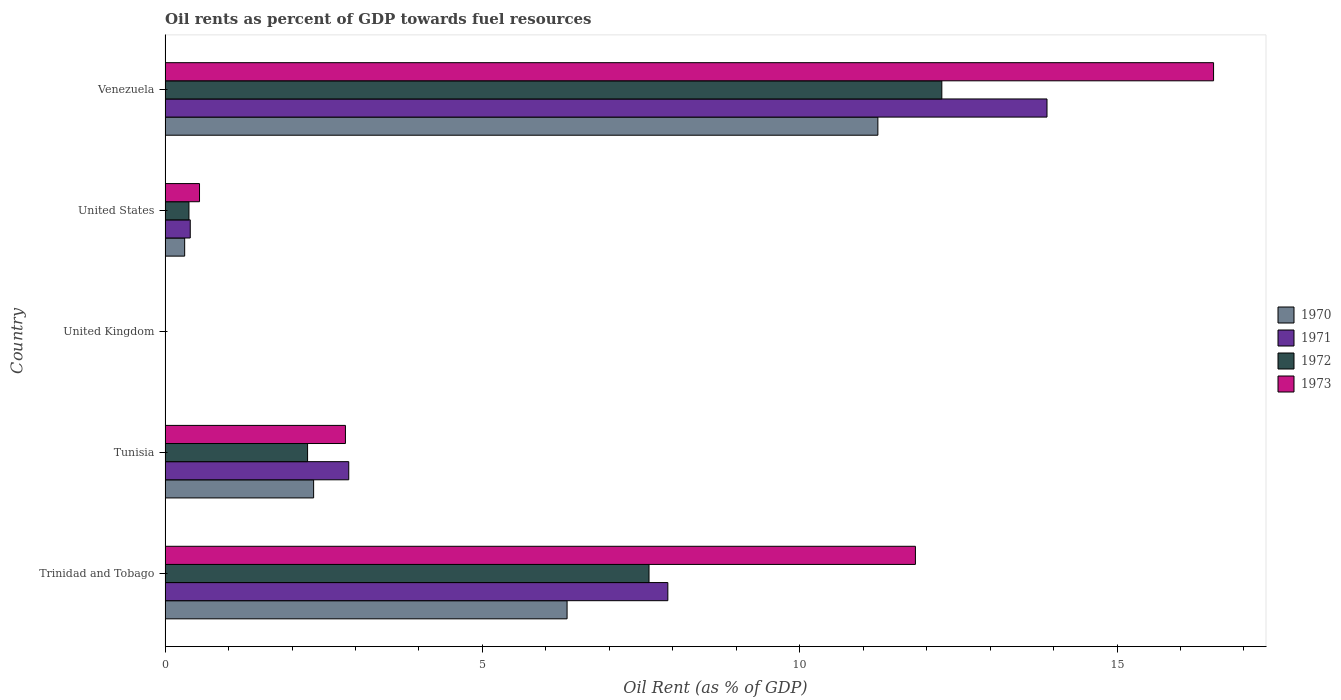How many bars are there on the 5th tick from the top?
Provide a succinct answer. 4. How many bars are there on the 1st tick from the bottom?
Your response must be concise. 4. What is the label of the 5th group of bars from the top?
Your response must be concise. Trinidad and Tobago. What is the oil rent in 1973 in Tunisia?
Make the answer very short. 2.84. Across all countries, what is the maximum oil rent in 1973?
Your answer should be very brief. 16.52. Across all countries, what is the minimum oil rent in 1970?
Ensure brevity in your answer.  0. In which country was the oil rent in 1970 maximum?
Give a very brief answer. Venezuela. In which country was the oil rent in 1970 minimum?
Keep it short and to the point. United Kingdom. What is the total oil rent in 1972 in the graph?
Provide a short and direct response. 22.49. What is the difference between the oil rent in 1973 in United Kingdom and that in Venezuela?
Provide a short and direct response. -16.52. What is the difference between the oil rent in 1970 in Venezuela and the oil rent in 1972 in United States?
Give a very brief answer. 10.86. What is the average oil rent in 1973 per country?
Offer a very short reply. 6.35. What is the difference between the oil rent in 1972 and oil rent in 1973 in Trinidad and Tobago?
Your response must be concise. -4.2. What is the ratio of the oil rent in 1971 in United Kingdom to that in United States?
Provide a short and direct response. 0. Is the difference between the oil rent in 1972 in United Kingdom and Venezuela greater than the difference between the oil rent in 1973 in United Kingdom and Venezuela?
Your response must be concise. Yes. What is the difference between the highest and the second highest oil rent in 1973?
Provide a succinct answer. 4.7. What is the difference between the highest and the lowest oil rent in 1970?
Provide a succinct answer. 11.23. Is the sum of the oil rent in 1972 in Tunisia and Venezuela greater than the maximum oil rent in 1970 across all countries?
Provide a short and direct response. Yes. What does the 3rd bar from the top in United States represents?
Your answer should be very brief. 1971. What is the difference between two consecutive major ticks on the X-axis?
Ensure brevity in your answer.  5. Where does the legend appear in the graph?
Your response must be concise. Center right. How many legend labels are there?
Ensure brevity in your answer.  4. What is the title of the graph?
Keep it short and to the point. Oil rents as percent of GDP towards fuel resources. Does "1971" appear as one of the legend labels in the graph?
Make the answer very short. Yes. What is the label or title of the X-axis?
Make the answer very short. Oil Rent (as % of GDP). What is the label or title of the Y-axis?
Provide a succinct answer. Country. What is the Oil Rent (as % of GDP) of 1970 in Trinidad and Tobago?
Make the answer very short. 6.33. What is the Oil Rent (as % of GDP) in 1971 in Trinidad and Tobago?
Provide a short and direct response. 7.92. What is the Oil Rent (as % of GDP) of 1972 in Trinidad and Tobago?
Offer a terse response. 7.63. What is the Oil Rent (as % of GDP) in 1973 in Trinidad and Tobago?
Keep it short and to the point. 11.82. What is the Oil Rent (as % of GDP) of 1970 in Tunisia?
Your answer should be compact. 2.34. What is the Oil Rent (as % of GDP) in 1971 in Tunisia?
Ensure brevity in your answer.  2.89. What is the Oil Rent (as % of GDP) in 1972 in Tunisia?
Provide a succinct answer. 2.25. What is the Oil Rent (as % of GDP) in 1973 in Tunisia?
Your answer should be very brief. 2.84. What is the Oil Rent (as % of GDP) of 1970 in United Kingdom?
Your answer should be very brief. 0. What is the Oil Rent (as % of GDP) of 1971 in United Kingdom?
Your answer should be very brief. 0. What is the Oil Rent (as % of GDP) of 1972 in United Kingdom?
Give a very brief answer. 0. What is the Oil Rent (as % of GDP) of 1973 in United Kingdom?
Your answer should be very brief. 0. What is the Oil Rent (as % of GDP) of 1970 in United States?
Provide a short and direct response. 0.31. What is the Oil Rent (as % of GDP) of 1971 in United States?
Your answer should be very brief. 0.4. What is the Oil Rent (as % of GDP) in 1972 in United States?
Make the answer very short. 0.38. What is the Oil Rent (as % of GDP) of 1973 in United States?
Ensure brevity in your answer.  0.54. What is the Oil Rent (as % of GDP) in 1970 in Venezuela?
Ensure brevity in your answer.  11.23. What is the Oil Rent (as % of GDP) of 1971 in Venezuela?
Provide a succinct answer. 13.9. What is the Oil Rent (as % of GDP) in 1972 in Venezuela?
Give a very brief answer. 12.24. What is the Oil Rent (as % of GDP) of 1973 in Venezuela?
Offer a terse response. 16.52. Across all countries, what is the maximum Oil Rent (as % of GDP) of 1970?
Ensure brevity in your answer.  11.23. Across all countries, what is the maximum Oil Rent (as % of GDP) in 1971?
Give a very brief answer. 13.9. Across all countries, what is the maximum Oil Rent (as % of GDP) in 1972?
Make the answer very short. 12.24. Across all countries, what is the maximum Oil Rent (as % of GDP) in 1973?
Offer a very short reply. 16.52. Across all countries, what is the minimum Oil Rent (as % of GDP) of 1970?
Your response must be concise. 0. Across all countries, what is the minimum Oil Rent (as % of GDP) of 1971?
Offer a terse response. 0. Across all countries, what is the minimum Oil Rent (as % of GDP) in 1972?
Keep it short and to the point. 0. Across all countries, what is the minimum Oil Rent (as % of GDP) in 1973?
Offer a terse response. 0. What is the total Oil Rent (as % of GDP) in 1970 in the graph?
Make the answer very short. 20.22. What is the total Oil Rent (as % of GDP) in 1971 in the graph?
Provide a succinct answer. 25.11. What is the total Oil Rent (as % of GDP) of 1972 in the graph?
Your answer should be compact. 22.49. What is the total Oil Rent (as % of GDP) of 1973 in the graph?
Keep it short and to the point. 31.73. What is the difference between the Oil Rent (as % of GDP) in 1970 in Trinidad and Tobago and that in Tunisia?
Keep it short and to the point. 3.99. What is the difference between the Oil Rent (as % of GDP) of 1971 in Trinidad and Tobago and that in Tunisia?
Give a very brief answer. 5.03. What is the difference between the Oil Rent (as % of GDP) in 1972 in Trinidad and Tobago and that in Tunisia?
Your answer should be very brief. 5.38. What is the difference between the Oil Rent (as % of GDP) of 1973 in Trinidad and Tobago and that in Tunisia?
Provide a short and direct response. 8.98. What is the difference between the Oil Rent (as % of GDP) in 1970 in Trinidad and Tobago and that in United Kingdom?
Ensure brevity in your answer.  6.33. What is the difference between the Oil Rent (as % of GDP) of 1971 in Trinidad and Tobago and that in United Kingdom?
Provide a short and direct response. 7.92. What is the difference between the Oil Rent (as % of GDP) of 1972 in Trinidad and Tobago and that in United Kingdom?
Keep it short and to the point. 7.62. What is the difference between the Oil Rent (as % of GDP) in 1973 in Trinidad and Tobago and that in United Kingdom?
Your response must be concise. 11.82. What is the difference between the Oil Rent (as % of GDP) of 1970 in Trinidad and Tobago and that in United States?
Your answer should be very brief. 6.03. What is the difference between the Oil Rent (as % of GDP) of 1971 in Trinidad and Tobago and that in United States?
Offer a terse response. 7.53. What is the difference between the Oil Rent (as % of GDP) in 1972 in Trinidad and Tobago and that in United States?
Give a very brief answer. 7.25. What is the difference between the Oil Rent (as % of GDP) of 1973 in Trinidad and Tobago and that in United States?
Make the answer very short. 11.28. What is the difference between the Oil Rent (as % of GDP) of 1970 in Trinidad and Tobago and that in Venezuela?
Offer a terse response. -4.9. What is the difference between the Oil Rent (as % of GDP) of 1971 in Trinidad and Tobago and that in Venezuela?
Offer a terse response. -5.97. What is the difference between the Oil Rent (as % of GDP) in 1972 in Trinidad and Tobago and that in Venezuela?
Make the answer very short. -4.61. What is the difference between the Oil Rent (as % of GDP) of 1973 in Trinidad and Tobago and that in Venezuela?
Make the answer very short. -4.7. What is the difference between the Oil Rent (as % of GDP) in 1970 in Tunisia and that in United Kingdom?
Give a very brief answer. 2.34. What is the difference between the Oil Rent (as % of GDP) of 1971 in Tunisia and that in United Kingdom?
Ensure brevity in your answer.  2.89. What is the difference between the Oil Rent (as % of GDP) in 1972 in Tunisia and that in United Kingdom?
Ensure brevity in your answer.  2.24. What is the difference between the Oil Rent (as % of GDP) in 1973 in Tunisia and that in United Kingdom?
Your response must be concise. 2.84. What is the difference between the Oil Rent (as % of GDP) in 1970 in Tunisia and that in United States?
Ensure brevity in your answer.  2.03. What is the difference between the Oil Rent (as % of GDP) of 1971 in Tunisia and that in United States?
Provide a short and direct response. 2.5. What is the difference between the Oil Rent (as % of GDP) of 1972 in Tunisia and that in United States?
Provide a succinct answer. 1.87. What is the difference between the Oil Rent (as % of GDP) of 1973 in Tunisia and that in United States?
Offer a very short reply. 2.3. What is the difference between the Oil Rent (as % of GDP) of 1970 in Tunisia and that in Venezuela?
Provide a succinct answer. -8.89. What is the difference between the Oil Rent (as % of GDP) in 1971 in Tunisia and that in Venezuela?
Your response must be concise. -11. What is the difference between the Oil Rent (as % of GDP) in 1972 in Tunisia and that in Venezuela?
Your response must be concise. -9.99. What is the difference between the Oil Rent (as % of GDP) in 1973 in Tunisia and that in Venezuela?
Ensure brevity in your answer.  -13.68. What is the difference between the Oil Rent (as % of GDP) of 1970 in United Kingdom and that in United States?
Your answer should be very brief. -0.31. What is the difference between the Oil Rent (as % of GDP) of 1971 in United Kingdom and that in United States?
Your answer should be very brief. -0.4. What is the difference between the Oil Rent (as % of GDP) in 1972 in United Kingdom and that in United States?
Offer a very short reply. -0.37. What is the difference between the Oil Rent (as % of GDP) in 1973 in United Kingdom and that in United States?
Your answer should be very brief. -0.54. What is the difference between the Oil Rent (as % of GDP) in 1970 in United Kingdom and that in Venezuela?
Your answer should be very brief. -11.23. What is the difference between the Oil Rent (as % of GDP) of 1971 in United Kingdom and that in Venezuela?
Your answer should be very brief. -13.9. What is the difference between the Oil Rent (as % of GDP) in 1972 in United Kingdom and that in Venezuela?
Give a very brief answer. -12.24. What is the difference between the Oil Rent (as % of GDP) of 1973 in United Kingdom and that in Venezuela?
Your answer should be very brief. -16.52. What is the difference between the Oil Rent (as % of GDP) in 1970 in United States and that in Venezuela?
Offer a very short reply. -10.92. What is the difference between the Oil Rent (as % of GDP) of 1971 in United States and that in Venezuela?
Keep it short and to the point. -13.5. What is the difference between the Oil Rent (as % of GDP) in 1972 in United States and that in Venezuela?
Offer a terse response. -11.86. What is the difference between the Oil Rent (as % of GDP) of 1973 in United States and that in Venezuela?
Provide a succinct answer. -15.98. What is the difference between the Oil Rent (as % of GDP) in 1970 in Trinidad and Tobago and the Oil Rent (as % of GDP) in 1971 in Tunisia?
Your response must be concise. 3.44. What is the difference between the Oil Rent (as % of GDP) of 1970 in Trinidad and Tobago and the Oil Rent (as % of GDP) of 1972 in Tunisia?
Your answer should be very brief. 4.09. What is the difference between the Oil Rent (as % of GDP) in 1970 in Trinidad and Tobago and the Oil Rent (as % of GDP) in 1973 in Tunisia?
Offer a very short reply. 3.49. What is the difference between the Oil Rent (as % of GDP) in 1971 in Trinidad and Tobago and the Oil Rent (as % of GDP) in 1972 in Tunisia?
Keep it short and to the point. 5.68. What is the difference between the Oil Rent (as % of GDP) of 1971 in Trinidad and Tobago and the Oil Rent (as % of GDP) of 1973 in Tunisia?
Your response must be concise. 5.08. What is the difference between the Oil Rent (as % of GDP) in 1972 in Trinidad and Tobago and the Oil Rent (as % of GDP) in 1973 in Tunisia?
Your response must be concise. 4.78. What is the difference between the Oil Rent (as % of GDP) of 1970 in Trinidad and Tobago and the Oil Rent (as % of GDP) of 1971 in United Kingdom?
Provide a short and direct response. 6.33. What is the difference between the Oil Rent (as % of GDP) of 1970 in Trinidad and Tobago and the Oil Rent (as % of GDP) of 1972 in United Kingdom?
Ensure brevity in your answer.  6.33. What is the difference between the Oil Rent (as % of GDP) in 1970 in Trinidad and Tobago and the Oil Rent (as % of GDP) in 1973 in United Kingdom?
Give a very brief answer. 6.33. What is the difference between the Oil Rent (as % of GDP) in 1971 in Trinidad and Tobago and the Oil Rent (as % of GDP) in 1972 in United Kingdom?
Keep it short and to the point. 7.92. What is the difference between the Oil Rent (as % of GDP) of 1971 in Trinidad and Tobago and the Oil Rent (as % of GDP) of 1973 in United Kingdom?
Offer a very short reply. 7.92. What is the difference between the Oil Rent (as % of GDP) of 1972 in Trinidad and Tobago and the Oil Rent (as % of GDP) of 1973 in United Kingdom?
Give a very brief answer. 7.62. What is the difference between the Oil Rent (as % of GDP) in 1970 in Trinidad and Tobago and the Oil Rent (as % of GDP) in 1971 in United States?
Provide a succinct answer. 5.94. What is the difference between the Oil Rent (as % of GDP) in 1970 in Trinidad and Tobago and the Oil Rent (as % of GDP) in 1972 in United States?
Your response must be concise. 5.96. What is the difference between the Oil Rent (as % of GDP) in 1970 in Trinidad and Tobago and the Oil Rent (as % of GDP) in 1973 in United States?
Provide a short and direct response. 5.79. What is the difference between the Oil Rent (as % of GDP) of 1971 in Trinidad and Tobago and the Oil Rent (as % of GDP) of 1972 in United States?
Provide a succinct answer. 7.55. What is the difference between the Oil Rent (as % of GDP) in 1971 in Trinidad and Tobago and the Oil Rent (as % of GDP) in 1973 in United States?
Give a very brief answer. 7.38. What is the difference between the Oil Rent (as % of GDP) in 1972 in Trinidad and Tobago and the Oil Rent (as % of GDP) in 1973 in United States?
Keep it short and to the point. 7.08. What is the difference between the Oil Rent (as % of GDP) of 1970 in Trinidad and Tobago and the Oil Rent (as % of GDP) of 1971 in Venezuela?
Make the answer very short. -7.56. What is the difference between the Oil Rent (as % of GDP) in 1970 in Trinidad and Tobago and the Oil Rent (as % of GDP) in 1972 in Venezuela?
Your response must be concise. -5.91. What is the difference between the Oil Rent (as % of GDP) in 1970 in Trinidad and Tobago and the Oil Rent (as % of GDP) in 1973 in Venezuela?
Provide a short and direct response. -10.19. What is the difference between the Oil Rent (as % of GDP) in 1971 in Trinidad and Tobago and the Oil Rent (as % of GDP) in 1972 in Venezuela?
Provide a short and direct response. -4.32. What is the difference between the Oil Rent (as % of GDP) of 1971 in Trinidad and Tobago and the Oil Rent (as % of GDP) of 1973 in Venezuela?
Your response must be concise. -8.6. What is the difference between the Oil Rent (as % of GDP) in 1972 in Trinidad and Tobago and the Oil Rent (as % of GDP) in 1973 in Venezuela?
Offer a very short reply. -8.9. What is the difference between the Oil Rent (as % of GDP) in 1970 in Tunisia and the Oil Rent (as % of GDP) in 1971 in United Kingdom?
Give a very brief answer. 2.34. What is the difference between the Oil Rent (as % of GDP) of 1970 in Tunisia and the Oil Rent (as % of GDP) of 1972 in United Kingdom?
Make the answer very short. 2.34. What is the difference between the Oil Rent (as % of GDP) of 1970 in Tunisia and the Oil Rent (as % of GDP) of 1973 in United Kingdom?
Keep it short and to the point. 2.34. What is the difference between the Oil Rent (as % of GDP) of 1971 in Tunisia and the Oil Rent (as % of GDP) of 1972 in United Kingdom?
Provide a succinct answer. 2.89. What is the difference between the Oil Rent (as % of GDP) in 1971 in Tunisia and the Oil Rent (as % of GDP) in 1973 in United Kingdom?
Offer a terse response. 2.89. What is the difference between the Oil Rent (as % of GDP) in 1972 in Tunisia and the Oil Rent (as % of GDP) in 1973 in United Kingdom?
Your answer should be very brief. 2.24. What is the difference between the Oil Rent (as % of GDP) in 1970 in Tunisia and the Oil Rent (as % of GDP) in 1971 in United States?
Provide a short and direct response. 1.94. What is the difference between the Oil Rent (as % of GDP) in 1970 in Tunisia and the Oil Rent (as % of GDP) in 1972 in United States?
Offer a terse response. 1.96. What is the difference between the Oil Rent (as % of GDP) in 1970 in Tunisia and the Oil Rent (as % of GDP) in 1973 in United States?
Give a very brief answer. 1.8. What is the difference between the Oil Rent (as % of GDP) of 1971 in Tunisia and the Oil Rent (as % of GDP) of 1972 in United States?
Keep it short and to the point. 2.52. What is the difference between the Oil Rent (as % of GDP) in 1971 in Tunisia and the Oil Rent (as % of GDP) in 1973 in United States?
Your answer should be compact. 2.35. What is the difference between the Oil Rent (as % of GDP) of 1972 in Tunisia and the Oil Rent (as % of GDP) of 1973 in United States?
Offer a very short reply. 1.7. What is the difference between the Oil Rent (as % of GDP) in 1970 in Tunisia and the Oil Rent (as % of GDP) in 1971 in Venezuela?
Offer a terse response. -11.56. What is the difference between the Oil Rent (as % of GDP) of 1970 in Tunisia and the Oil Rent (as % of GDP) of 1972 in Venezuela?
Your answer should be compact. -9.9. What is the difference between the Oil Rent (as % of GDP) in 1970 in Tunisia and the Oil Rent (as % of GDP) in 1973 in Venezuela?
Make the answer very short. -14.18. What is the difference between the Oil Rent (as % of GDP) of 1971 in Tunisia and the Oil Rent (as % of GDP) of 1972 in Venezuela?
Make the answer very short. -9.35. What is the difference between the Oil Rent (as % of GDP) of 1971 in Tunisia and the Oil Rent (as % of GDP) of 1973 in Venezuela?
Offer a terse response. -13.63. What is the difference between the Oil Rent (as % of GDP) of 1972 in Tunisia and the Oil Rent (as % of GDP) of 1973 in Venezuela?
Offer a terse response. -14.28. What is the difference between the Oil Rent (as % of GDP) in 1970 in United Kingdom and the Oil Rent (as % of GDP) in 1971 in United States?
Your response must be concise. -0.4. What is the difference between the Oil Rent (as % of GDP) in 1970 in United Kingdom and the Oil Rent (as % of GDP) in 1972 in United States?
Provide a short and direct response. -0.38. What is the difference between the Oil Rent (as % of GDP) in 1970 in United Kingdom and the Oil Rent (as % of GDP) in 1973 in United States?
Offer a terse response. -0.54. What is the difference between the Oil Rent (as % of GDP) of 1971 in United Kingdom and the Oil Rent (as % of GDP) of 1972 in United States?
Give a very brief answer. -0.38. What is the difference between the Oil Rent (as % of GDP) of 1971 in United Kingdom and the Oil Rent (as % of GDP) of 1973 in United States?
Your answer should be very brief. -0.54. What is the difference between the Oil Rent (as % of GDP) in 1972 in United Kingdom and the Oil Rent (as % of GDP) in 1973 in United States?
Make the answer very short. -0.54. What is the difference between the Oil Rent (as % of GDP) of 1970 in United Kingdom and the Oil Rent (as % of GDP) of 1971 in Venezuela?
Ensure brevity in your answer.  -13.9. What is the difference between the Oil Rent (as % of GDP) in 1970 in United Kingdom and the Oil Rent (as % of GDP) in 1972 in Venezuela?
Keep it short and to the point. -12.24. What is the difference between the Oil Rent (as % of GDP) in 1970 in United Kingdom and the Oil Rent (as % of GDP) in 1973 in Venezuela?
Offer a very short reply. -16.52. What is the difference between the Oil Rent (as % of GDP) in 1971 in United Kingdom and the Oil Rent (as % of GDP) in 1972 in Venezuela?
Give a very brief answer. -12.24. What is the difference between the Oil Rent (as % of GDP) in 1971 in United Kingdom and the Oil Rent (as % of GDP) in 1973 in Venezuela?
Offer a terse response. -16.52. What is the difference between the Oil Rent (as % of GDP) in 1972 in United Kingdom and the Oil Rent (as % of GDP) in 1973 in Venezuela?
Make the answer very short. -16.52. What is the difference between the Oil Rent (as % of GDP) of 1970 in United States and the Oil Rent (as % of GDP) of 1971 in Venezuela?
Your response must be concise. -13.59. What is the difference between the Oil Rent (as % of GDP) in 1970 in United States and the Oil Rent (as % of GDP) in 1972 in Venezuela?
Your answer should be compact. -11.93. What is the difference between the Oil Rent (as % of GDP) of 1970 in United States and the Oil Rent (as % of GDP) of 1973 in Venezuela?
Your answer should be very brief. -16.21. What is the difference between the Oil Rent (as % of GDP) in 1971 in United States and the Oil Rent (as % of GDP) in 1972 in Venezuela?
Offer a very short reply. -11.84. What is the difference between the Oil Rent (as % of GDP) of 1971 in United States and the Oil Rent (as % of GDP) of 1973 in Venezuela?
Ensure brevity in your answer.  -16.12. What is the difference between the Oil Rent (as % of GDP) in 1972 in United States and the Oil Rent (as % of GDP) in 1973 in Venezuela?
Your response must be concise. -16.15. What is the average Oil Rent (as % of GDP) of 1970 per country?
Your response must be concise. 4.04. What is the average Oil Rent (as % of GDP) in 1971 per country?
Your answer should be compact. 5.02. What is the average Oil Rent (as % of GDP) of 1972 per country?
Ensure brevity in your answer.  4.5. What is the average Oil Rent (as % of GDP) in 1973 per country?
Provide a succinct answer. 6.35. What is the difference between the Oil Rent (as % of GDP) in 1970 and Oil Rent (as % of GDP) in 1971 in Trinidad and Tobago?
Ensure brevity in your answer.  -1.59. What is the difference between the Oil Rent (as % of GDP) in 1970 and Oil Rent (as % of GDP) in 1972 in Trinidad and Tobago?
Your answer should be very brief. -1.29. What is the difference between the Oil Rent (as % of GDP) in 1970 and Oil Rent (as % of GDP) in 1973 in Trinidad and Tobago?
Provide a succinct answer. -5.49. What is the difference between the Oil Rent (as % of GDP) in 1971 and Oil Rent (as % of GDP) in 1972 in Trinidad and Tobago?
Offer a terse response. 0.3. What is the difference between the Oil Rent (as % of GDP) in 1971 and Oil Rent (as % of GDP) in 1973 in Trinidad and Tobago?
Offer a terse response. -3.9. What is the difference between the Oil Rent (as % of GDP) of 1972 and Oil Rent (as % of GDP) of 1973 in Trinidad and Tobago?
Keep it short and to the point. -4.2. What is the difference between the Oil Rent (as % of GDP) in 1970 and Oil Rent (as % of GDP) in 1971 in Tunisia?
Offer a terse response. -0.55. What is the difference between the Oil Rent (as % of GDP) in 1970 and Oil Rent (as % of GDP) in 1972 in Tunisia?
Give a very brief answer. 0.1. What is the difference between the Oil Rent (as % of GDP) in 1970 and Oil Rent (as % of GDP) in 1973 in Tunisia?
Provide a succinct answer. -0.5. What is the difference between the Oil Rent (as % of GDP) of 1971 and Oil Rent (as % of GDP) of 1972 in Tunisia?
Offer a terse response. 0.65. What is the difference between the Oil Rent (as % of GDP) of 1971 and Oil Rent (as % of GDP) of 1973 in Tunisia?
Your response must be concise. 0.05. What is the difference between the Oil Rent (as % of GDP) of 1972 and Oil Rent (as % of GDP) of 1973 in Tunisia?
Keep it short and to the point. -0.6. What is the difference between the Oil Rent (as % of GDP) in 1970 and Oil Rent (as % of GDP) in 1971 in United Kingdom?
Provide a short and direct response. 0. What is the difference between the Oil Rent (as % of GDP) in 1970 and Oil Rent (as % of GDP) in 1972 in United Kingdom?
Keep it short and to the point. -0. What is the difference between the Oil Rent (as % of GDP) in 1970 and Oil Rent (as % of GDP) in 1973 in United Kingdom?
Ensure brevity in your answer.  -0. What is the difference between the Oil Rent (as % of GDP) of 1971 and Oil Rent (as % of GDP) of 1972 in United Kingdom?
Your response must be concise. -0. What is the difference between the Oil Rent (as % of GDP) in 1971 and Oil Rent (as % of GDP) in 1973 in United Kingdom?
Make the answer very short. -0. What is the difference between the Oil Rent (as % of GDP) in 1972 and Oil Rent (as % of GDP) in 1973 in United Kingdom?
Your response must be concise. -0. What is the difference between the Oil Rent (as % of GDP) of 1970 and Oil Rent (as % of GDP) of 1971 in United States?
Ensure brevity in your answer.  -0.09. What is the difference between the Oil Rent (as % of GDP) of 1970 and Oil Rent (as % of GDP) of 1972 in United States?
Give a very brief answer. -0.07. What is the difference between the Oil Rent (as % of GDP) in 1970 and Oil Rent (as % of GDP) in 1973 in United States?
Your answer should be compact. -0.23. What is the difference between the Oil Rent (as % of GDP) of 1971 and Oil Rent (as % of GDP) of 1972 in United States?
Your answer should be compact. 0.02. What is the difference between the Oil Rent (as % of GDP) of 1971 and Oil Rent (as % of GDP) of 1973 in United States?
Your response must be concise. -0.15. What is the difference between the Oil Rent (as % of GDP) in 1972 and Oil Rent (as % of GDP) in 1973 in United States?
Offer a terse response. -0.17. What is the difference between the Oil Rent (as % of GDP) in 1970 and Oil Rent (as % of GDP) in 1971 in Venezuela?
Keep it short and to the point. -2.67. What is the difference between the Oil Rent (as % of GDP) in 1970 and Oil Rent (as % of GDP) in 1972 in Venezuela?
Give a very brief answer. -1.01. What is the difference between the Oil Rent (as % of GDP) in 1970 and Oil Rent (as % of GDP) in 1973 in Venezuela?
Provide a short and direct response. -5.29. What is the difference between the Oil Rent (as % of GDP) in 1971 and Oil Rent (as % of GDP) in 1972 in Venezuela?
Make the answer very short. 1.66. What is the difference between the Oil Rent (as % of GDP) of 1971 and Oil Rent (as % of GDP) of 1973 in Venezuela?
Provide a succinct answer. -2.62. What is the difference between the Oil Rent (as % of GDP) in 1972 and Oil Rent (as % of GDP) in 1973 in Venezuela?
Give a very brief answer. -4.28. What is the ratio of the Oil Rent (as % of GDP) of 1970 in Trinidad and Tobago to that in Tunisia?
Provide a short and direct response. 2.71. What is the ratio of the Oil Rent (as % of GDP) of 1971 in Trinidad and Tobago to that in Tunisia?
Your answer should be compact. 2.74. What is the ratio of the Oil Rent (as % of GDP) in 1972 in Trinidad and Tobago to that in Tunisia?
Your answer should be compact. 3.4. What is the ratio of the Oil Rent (as % of GDP) in 1973 in Trinidad and Tobago to that in Tunisia?
Offer a very short reply. 4.16. What is the ratio of the Oil Rent (as % of GDP) in 1970 in Trinidad and Tobago to that in United Kingdom?
Give a very brief answer. 7151.98. What is the ratio of the Oil Rent (as % of GDP) of 1971 in Trinidad and Tobago to that in United Kingdom?
Keep it short and to the point. 1.12e+04. What is the ratio of the Oil Rent (as % of GDP) of 1972 in Trinidad and Tobago to that in United Kingdom?
Your response must be concise. 5894.4. What is the ratio of the Oil Rent (as % of GDP) in 1973 in Trinidad and Tobago to that in United Kingdom?
Offer a very short reply. 5268.85. What is the ratio of the Oil Rent (as % of GDP) of 1970 in Trinidad and Tobago to that in United States?
Offer a very short reply. 20.53. What is the ratio of the Oil Rent (as % of GDP) in 1971 in Trinidad and Tobago to that in United States?
Your answer should be very brief. 19.98. What is the ratio of the Oil Rent (as % of GDP) of 1972 in Trinidad and Tobago to that in United States?
Keep it short and to the point. 20.29. What is the ratio of the Oil Rent (as % of GDP) of 1973 in Trinidad and Tobago to that in United States?
Make the answer very short. 21.8. What is the ratio of the Oil Rent (as % of GDP) in 1970 in Trinidad and Tobago to that in Venezuela?
Give a very brief answer. 0.56. What is the ratio of the Oil Rent (as % of GDP) in 1971 in Trinidad and Tobago to that in Venezuela?
Offer a very short reply. 0.57. What is the ratio of the Oil Rent (as % of GDP) in 1972 in Trinidad and Tobago to that in Venezuela?
Offer a very short reply. 0.62. What is the ratio of the Oil Rent (as % of GDP) in 1973 in Trinidad and Tobago to that in Venezuela?
Give a very brief answer. 0.72. What is the ratio of the Oil Rent (as % of GDP) of 1970 in Tunisia to that in United Kingdom?
Your answer should be compact. 2642.42. What is the ratio of the Oil Rent (as % of GDP) of 1971 in Tunisia to that in United Kingdom?
Make the answer very short. 4088.61. What is the ratio of the Oil Rent (as % of GDP) in 1972 in Tunisia to that in United Kingdom?
Make the answer very short. 1735.44. What is the ratio of the Oil Rent (as % of GDP) of 1973 in Tunisia to that in United Kingdom?
Make the answer very short. 1266.39. What is the ratio of the Oil Rent (as % of GDP) in 1970 in Tunisia to that in United States?
Provide a succinct answer. 7.59. What is the ratio of the Oil Rent (as % of GDP) of 1971 in Tunisia to that in United States?
Offer a very short reply. 7.3. What is the ratio of the Oil Rent (as % of GDP) of 1972 in Tunisia to that in United States?
Offer a very short reply. 5.97. What is the ratio of the Oil Rent (as % of GDP) in 1973 in Tunisia to that in United States?
Offer a terse response. 5.24. What is the ratio of the Oil Rent (as % of GDP) in 1970 in Tunisia to that in Venezuela?
Your answer should be compact. 0.21. What is the ratio of the Oil Rent (as % of GDP) of 1971 in Tunisia to that in Venezuela?
Ensure brevity in your answer.  0.21. What is the ratio of the Oil Rent (as % of GDP) of 1972 in Tunisia to that in Venezuela?
Offer a very short reply. 0.18. What is the ratio of the Oil Rent (as % of GDP) in 1973 in Tunisia to that in Venezuela?
Provide a succinct answer. 0.17. What is the ratio of the Oil Rent (as % of GDP) of 1970 in United Kingdom to that in United States?
Offer a terse response. 0. What is the ratio of the Oil Rent (as % of GDP) in 1971 in United Kingdom to that in United States?
Your answer should be very brief. 0. What is the ratio of the Oil Rent (as % of GDP) in 1972 in United Kingdom to that in United States?
Your answer should be compact. 0. What is the ratio of the Oil Rent (as % of GDP) of 1973 in United Kingdom to that in United States?
Ensure brevity in your answer.  0. What is the ratio of the Oil Rent (as % of GDP) of 1971 in United Kingdom to that in Venezuela?
Your answer should be very brief. 0. What is the ratio of the Oil Rent (as % of GDP) in 1970 in United States to that in Venezuela?
Your answer should be very brief. 0.03. What is the ratio of the Oil Rent (as % of GDP) in 1971 in United States to that in Venezuela?
Your answer should be very brief. 0.03. What is the ratio of the Oil Rent (as % of GDP) in 1972 in United States to that in Venezuela?
Your answer should be very brief. 0.03. What is the ratio of the Oil Rent (as % of GDP) of 1973 in United States to that in Venezuela?
Your answer should be compact. 0.03. What is the difference between the highest and the second highest Oil Rent (as % of GDP) of 1970?
Provide a short and direct response. 4.9. What is the difference between the highest and the second highest Oil Rent (as % of GDP) in 1971?
Offer a terse response. 5.97. What is the difference between the highest and the second highest Oil Rent (as % of GDP) of 1972?
Your answer should be very brief. 4.61. What is the difference between the highest and the second highest Oil Rent (as % of GDP) of 1973?
Give a very brief answer. 4.7. What is the difference between the highest and the lowest Oil Rent (as % of GDP) of 1970?
Offer a very short reply. 11.23. What is the difference between the highest and the lowest Oil Rent (as % of GDP) in 1971?
Your answer should be very brief. 13.9. What is the difference between the highest and the lowest Oil Rent (as % of GDP) in 1972?
Offer a very short reply. 12.24. What is the difference between the highest and the lowest Oil Rent (as % of GDP) in 1973?
Ensure brevity in your answer.  16.52. 